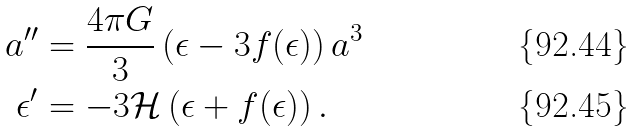Convert formula to latex. <formula><loc_0><loc_0><loc_500><loc_500>a ^ { \prime \prime } & = \frac { 4 \pi G } { 3 } \left ( \epsilon - 3 f ( \epsilon ) \right ) a ^ { 3 } \\ \epsilon ^ { \prime } & = - 3 \mathcal { H } \left ( \epsilon + f ( \epsilon ) \right ) .</formula> 